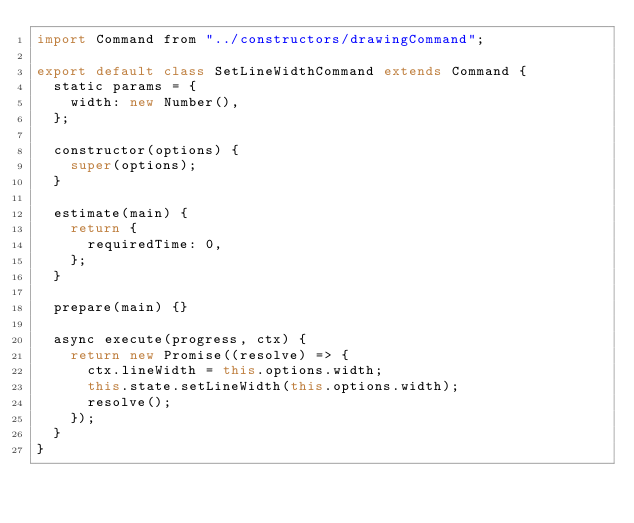<code> <loc_0><loc_0><loc_500><loc_500><_JavaScript_>import Command from "../constructors/drawingCommand";

export default class SetLineWidthCommand extends Command {
  static params = {
    width: new Number(),
  };

  constructor(options) {
    super(options);
  }

  estimate(main) {
    return {
      requiredTime: 0,
    };
  }

  prepare(main) {}

  async execute(progress, ctx) {
    return new Promise((resolve) => {
      ctx.lineWidth = this.options.width;
      this.state.setLineWidth(this.options.width);
      resolve();
    });
  }
}
</code> 